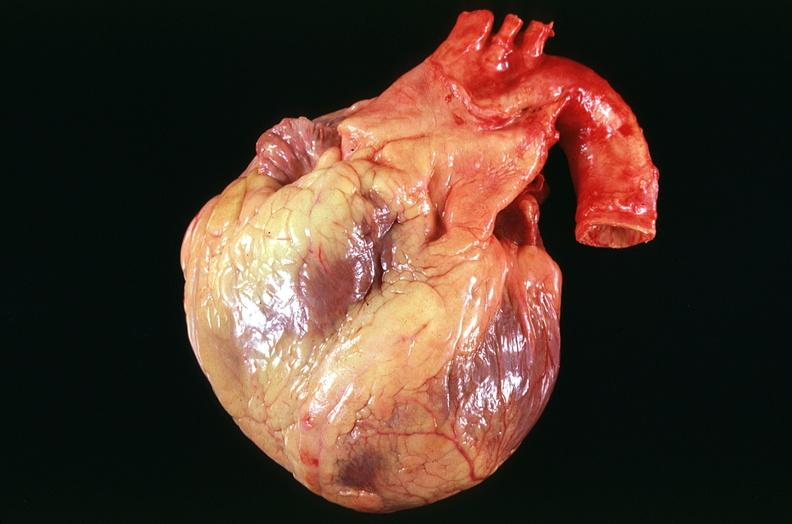does this image show congestive heart failure, three vessel coronary artery disease?
Answer the question using a single word or phrase. Yes 